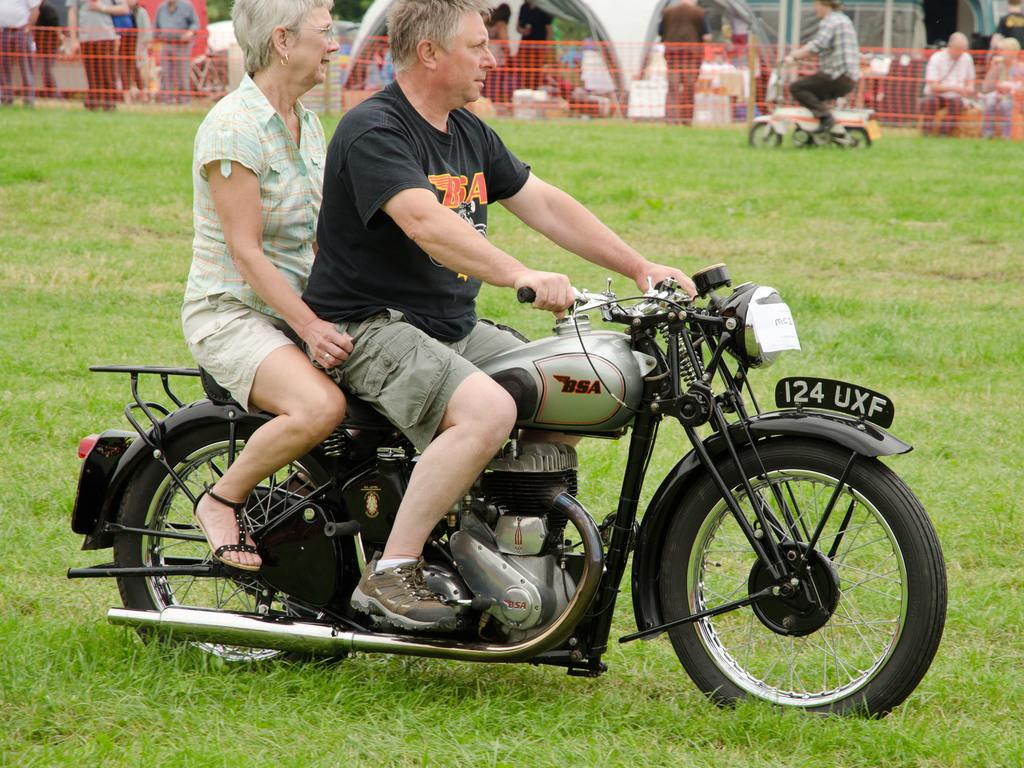Who is in the image? There is a man and a woman in the image. What are they doing in the image? They are on a bike. What can be seen in the background of the image? There are people in the background of the image. What are the people in the background doing? Some of the people in the background are sitting, and some are standing. What is the tendency of the vest in the image? There is no vest present in the image, so it is not possible to determine its tendency. 